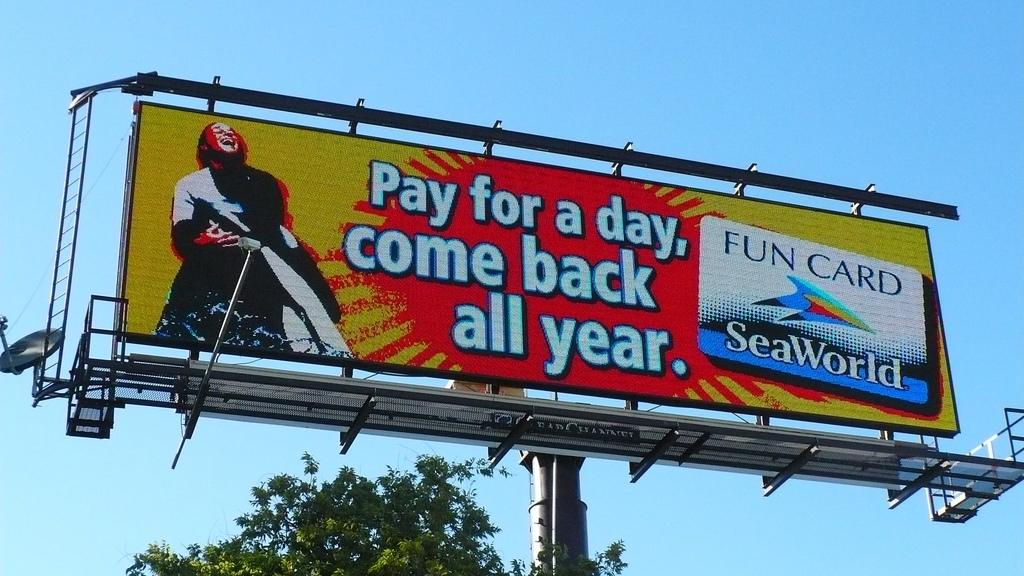<image>
Summarize the visual content of the image. A SeaWorld Fun Card is advertised on a billboard. 